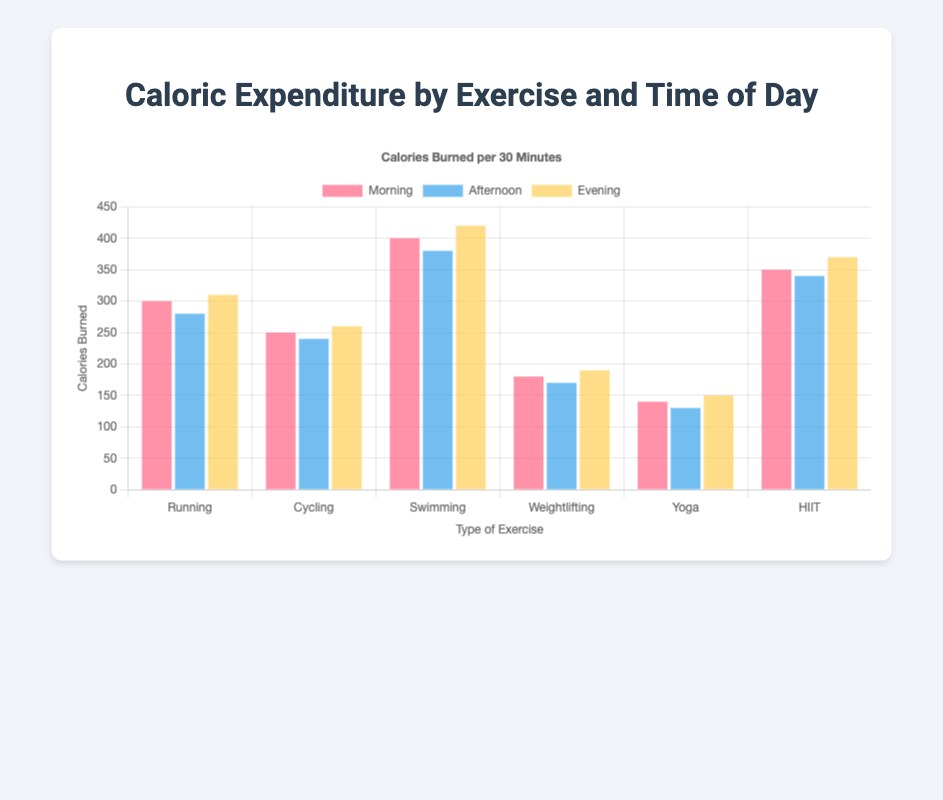Which exercise has the highest caloric expenditure in the morning? Looking at the bars that represent the morning time for each exercise, Swimming has the tallest bar, indicating the highest caloric expenditure.
Answer: Swimming By how many calories does Weightlifting's caloric expenditure increase from afternoon to evening? The caloric expenditure for Weightlifting in the afternoon is 170 calories, and in the evening is 190 calories. The increase is calculated as 190 - 170 = 20 calories.
Answer: 20 What is the average caloric expenditure for Running across all times of day? The caloric expenditures for Running are 300 in the morning, 280 in the afternoon, and 310 in the evening. Their sum is 300 + 280 + 310 = 890. The average is 890 / 3 = 296.67.
Answer: 296.67 Which exercise shows the least variation in caloric expenditure across different times of day? To determine the exercise with the least variation, calculate the range (difference between maximum and minimum values) for each exercise. Yoga's values are 140 (morning), 130 (afternoon), and 150 (evening), for a range of 150 - 130 = 20 calories. This is the smallest range compared to other exercises.
Answer: Yoga Compare the caloric expenditure of HIIT in the morning versus Yoga in the evening. The morning caloric expenditure for HIIT is 350 calories, and the evening caloric expenditure for Yoga is 150 calories. Comparing these, 350 is greater than 150.
Answer: HIIT What is the total caloric expenditure for Cycling throughout the day? The caloric expenditures for Cycling are 250 in the morning, 240 in the afternoon, and 260 in the evening. Their sum is 250 + 240 + 260 = 750 calories.
Answer: 750 How does the evening caloric expenditure of Running compare to that of Swimming? The evening caloric expenditures for Running and Swimming are 310 and 420 calories, respectively. Comparing these, Swimming has a higher expenditure.
Answer: Swimming What is the difference in caloric expenditure between Swimming and Weightlifting in the afternoon? The caloric expenditure for Swimming in the afternoon is 380 calories, and for Weightlifting is 170 calories. The difference is 380 - 170 = 210 calories.
Answer: 210 Which time of day generally shows the highest caloric expenditure for most exercises? Observing the visual height of the bars for each exercise category shows that the evening usually has the highest caloric expenditure compared to morning and afternoon for most exercises.
Answer: Evening 